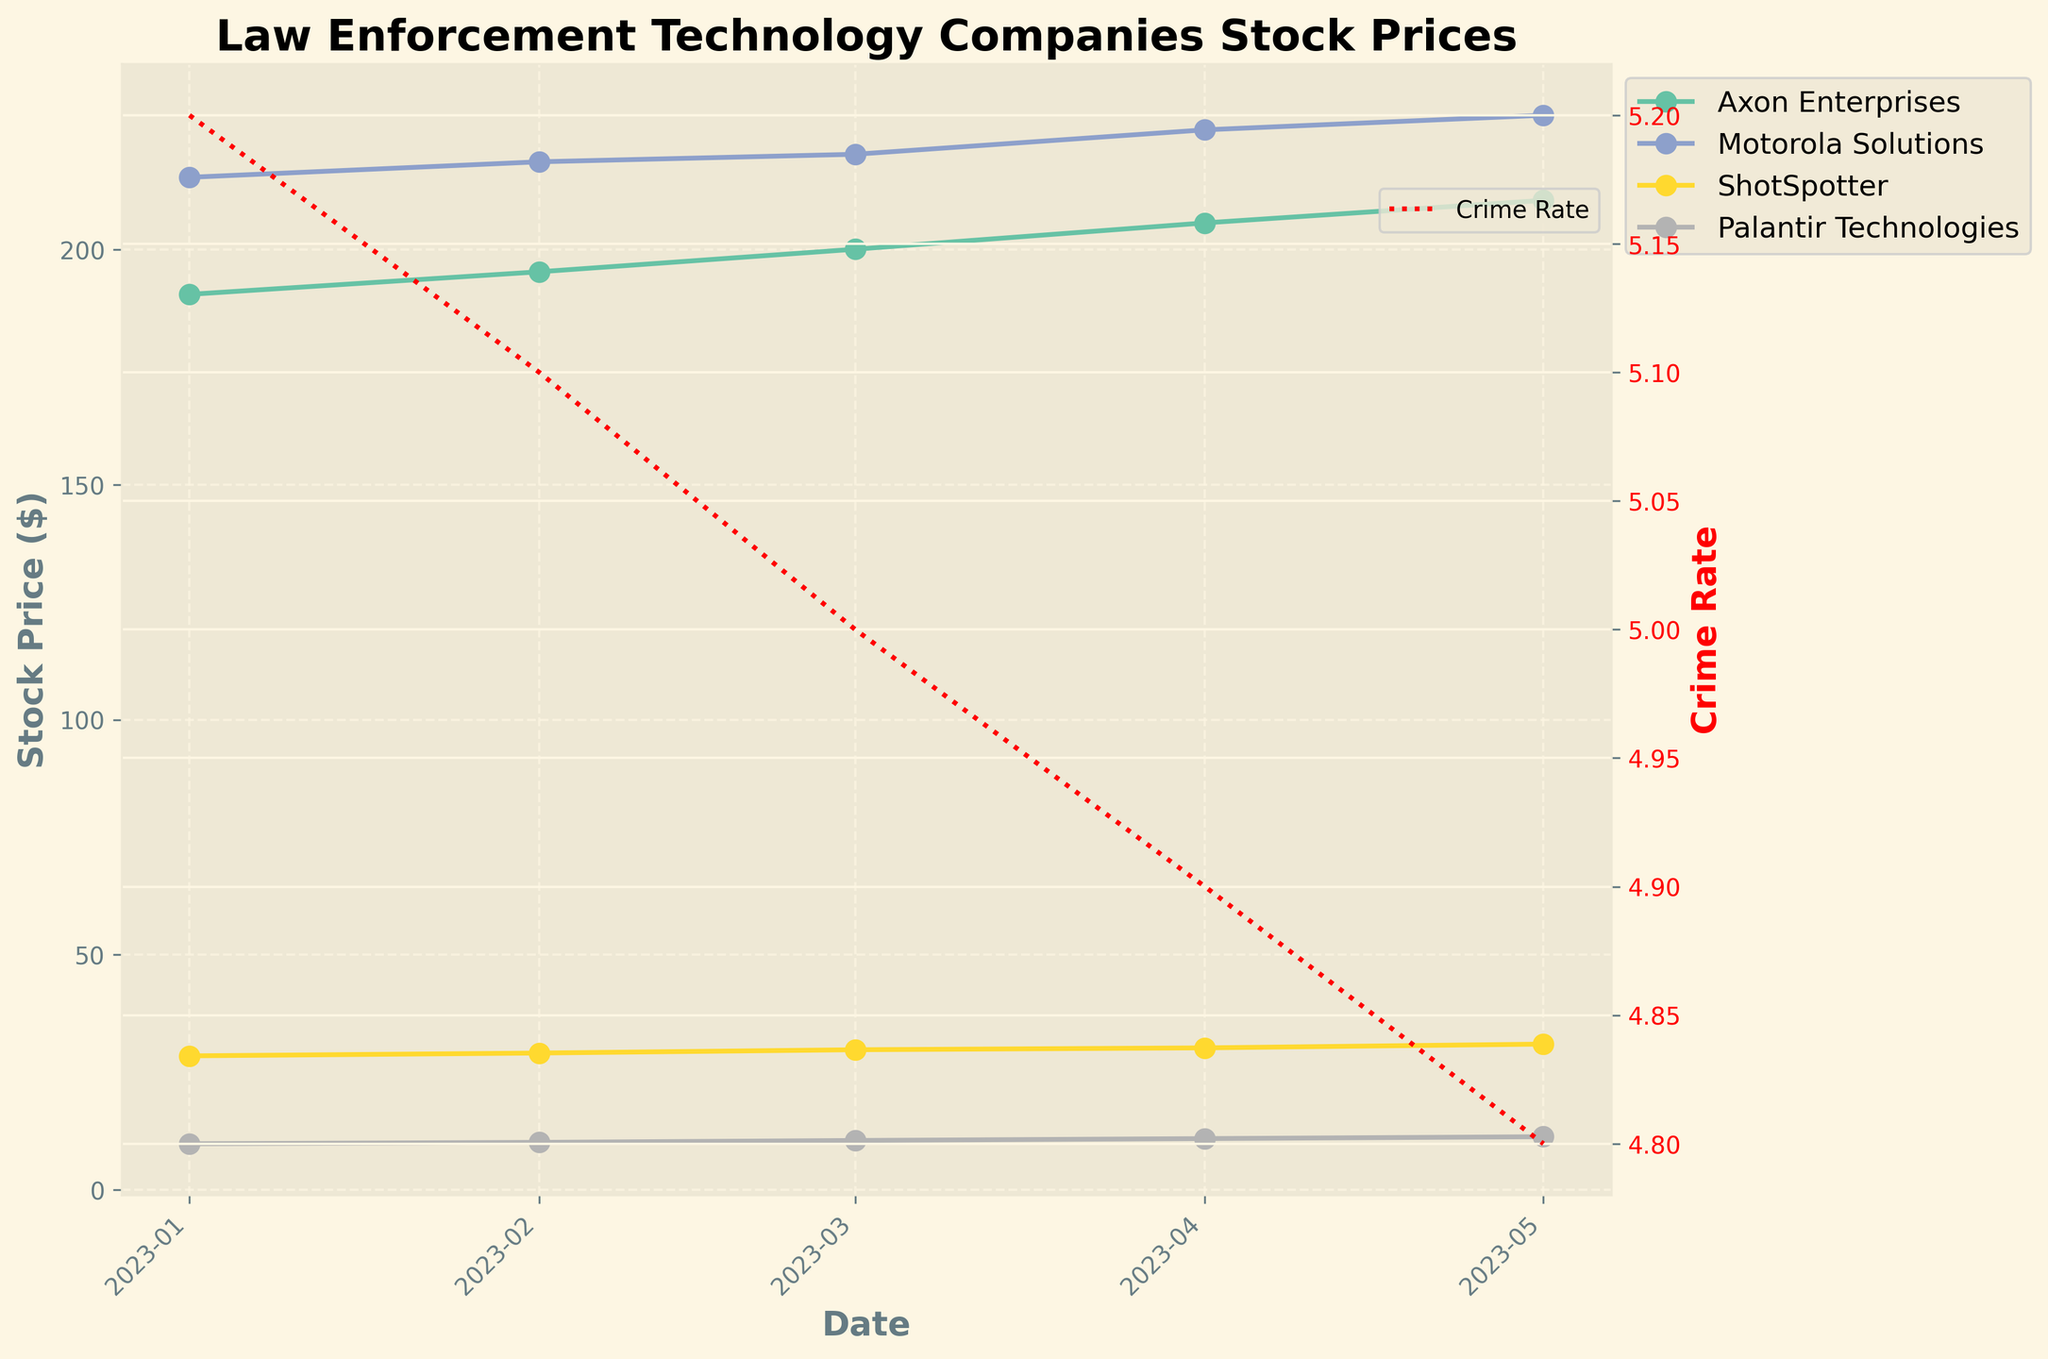What's the title of the plot? The title of the plot is displayed at the top center of the figure above the main chart area in bold font.
Answer: Law Enforcement Technology Companies Stock Prices Which company had the highest stock price on May 1, 2023? By examining the data points for May 1, 2023, and comparing the stock prices for each company, it's evident that Motorola Solutions had the highest stock price on that date.
Answer: Motorola Solutions How does the Crime Rate trend relate to the stock prices over time? The Crime Rate is depicted by the red dashed line plotted on the secondary y-axis (right side). This line shows a downward trend from January to May. Concurrently, the stock prices for all companies show an upward trend which suggests an inverse relationship where lower Crime Rates may correspond to higher stock prices for law enforcement technology companies.
Answer: They exhibit an inverse relationship By how much did the stock price of Axon Enterprises increase from January to May 2023? The stock price of Axon Enterprises was $190.5 in January and increased to $210.5 in May. The amount increased can be calculated as $210.5 - $190.5 = $20.
Answer: $20 Which company shows the most consistent increase in stock prices between January and May 2023? By examining the slope of the lines for each company between these months, Axon Enterprises and ShotSpotter seem to have the most consistent increase in their stock prices with a steady upward trend without significant fluctuations.
Answer: Axon Enterprises and ShotSpotter What's the overall trend of Motorola Solutions' stock price? Observing the plotted data for Motorola Solutions, the stock price consistently rises each month from January to May 2023.
Answer: Consistently increasing Compare the stock price change of Palantir Technologies and ShotSpotter between April 1, 2023, and May 1, 2023. Palantir Technologies' stock price increased from $10.9 in April to $11.3 in May, an increase of $0.4. ShotSpotter's stock price increased from $30.2 in April to $31.0 in May, an increase of $0.8.
Answer: ShotSpotter increased by $0.8, Palantir Technologies by $0.4 What pattern or insight can you deduce from the twin plot of stock prices and crime rates? The twin plot, which charts both stock prices and crime rates, reveals that as crime rates decreased steadily from January to May, the stock prices of law enforcement technology companies tended to rise. This suggests that investors may have confidence in these companies' growth as they might be seen as effective in reducing crime rates.
Answer: Lower crime rates correlate with higher stock prices Between which months did ShotSpotter experience the highest growth in stock price? ShotSpotter’s stock prices are plotted and show incremental changes each month. The highest monthly growth, determined by the steepest section of the curve, is observed between April and May when the stock increased from $30.2 to $31.0, a growth of $0.8.
Answer: April to May 